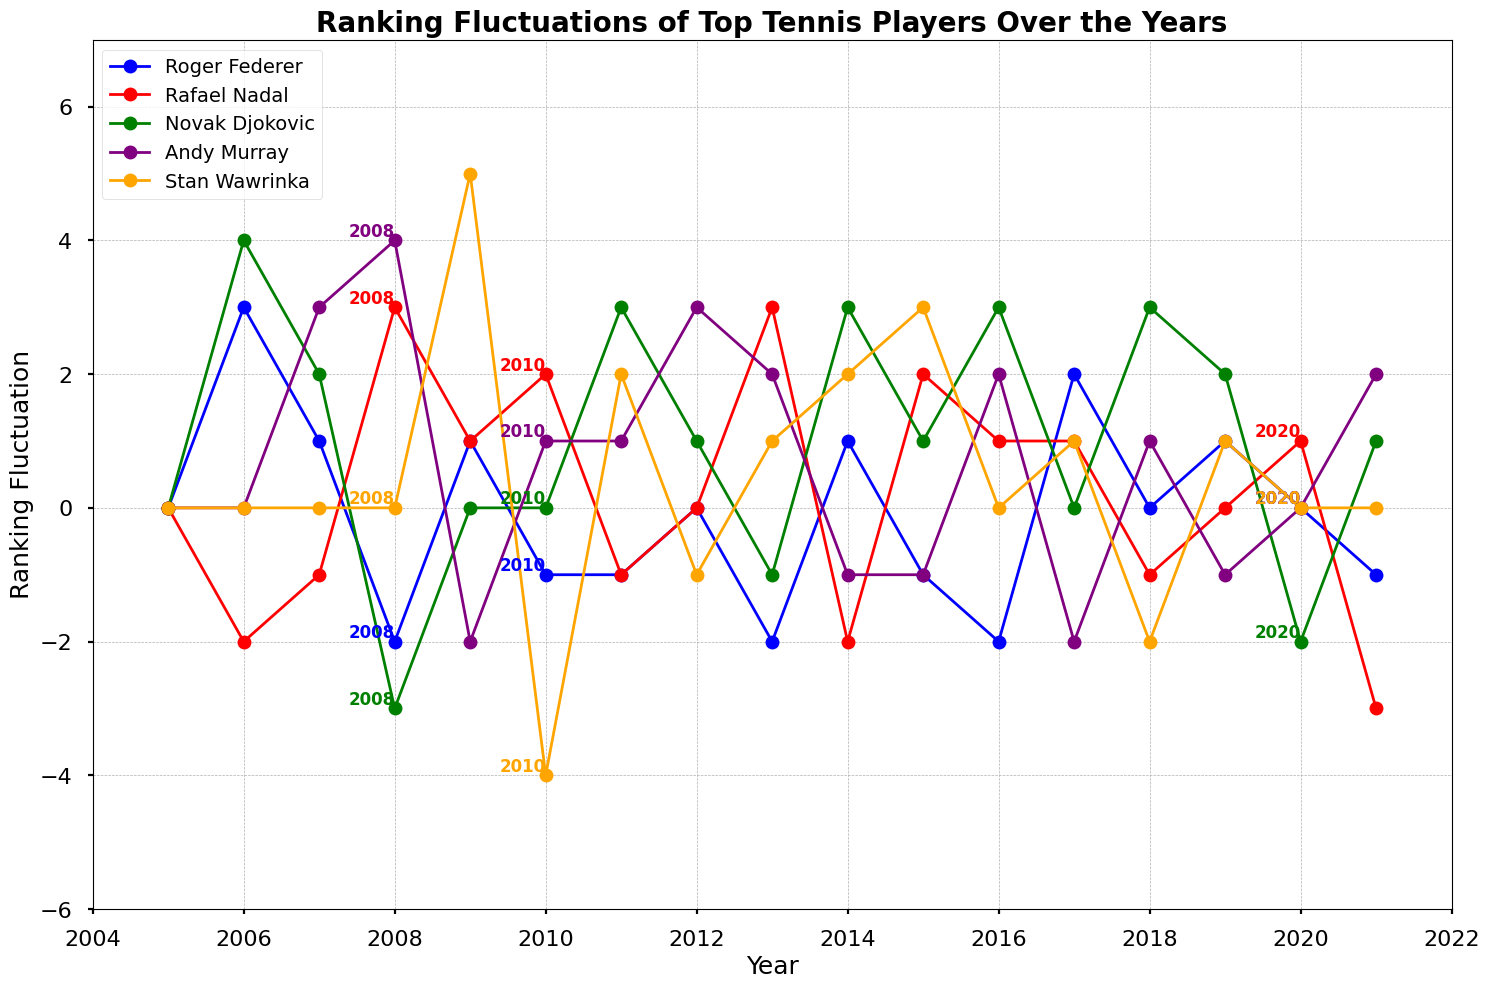Which player had the largest negative fluctuation in ranking in 2021? In 2021, Rafael Nadal had a fluctuation of -3. To find the largest negative fluctuation, we compare the negative values, and -3 is the most negative.
Answer: Rafael Nadal During which year did Andy Murray experience the largest positive fluctuation in ranking? To identify the largest positive fluctuation for Andy Murray, review his data points. The largest positive fluctuation (4) occurred between 2007 and 2008.
Answer: 2008 How did Stan Wawrinka's ranking fluctuate from 2009 to 2010? Looking at Stan Wawrinka's data points, his ranking went from 5 in 2009 to -4 in 2010. The fluctuation is computed as -4 - 5 = -9.
Answer: -9 Which player had a positive ranking fluctuation in both 2012 and 2013? Review each player's data for both years. Andy Murray showed positive fluctuations in both 2012 (3) and 2013 (2).
Answer: Andy Murray Was there any year where Novak Djokovic had a ranking fluctuation of exactly 0? Examine Novak Djokovic’s data for all years and find the instances where the value is 0, occurring in 2005, 2009, and 2017.
Answer: Yes, in 2005, 2009, and 2017 Compare the ranking fluctuations of Roger Federer and Rafael Nadal in 2008. Who had a larger shift? In 2008, Roger Federer had a fluctuation of -2 and Rafael Nadal had a fluctuation of 3. To compare them, we see that the absolute fluctuation of Rafael Nadal (3) is larger than Roger Federer's (2).
Answer: Rafael Nadal Summing up the ranking fluctuations for Andy Murray from 2010 to 2012, what is the total? Summing the fluctuations for Andy Murray: 1 (2010) + 1 (2011) + 3 (2012) gives 5.
Answer: 5 Which player's ranking fluctuation shows the greatest peak (both positive and negative) overall the years? Review all the players for the highest and lowest values. Stan Wawrinka has +5 in 2009 and -4 in 2010, making his range from -4 to 5 which covers 9 points.
Answer: Stan Wawrinka 